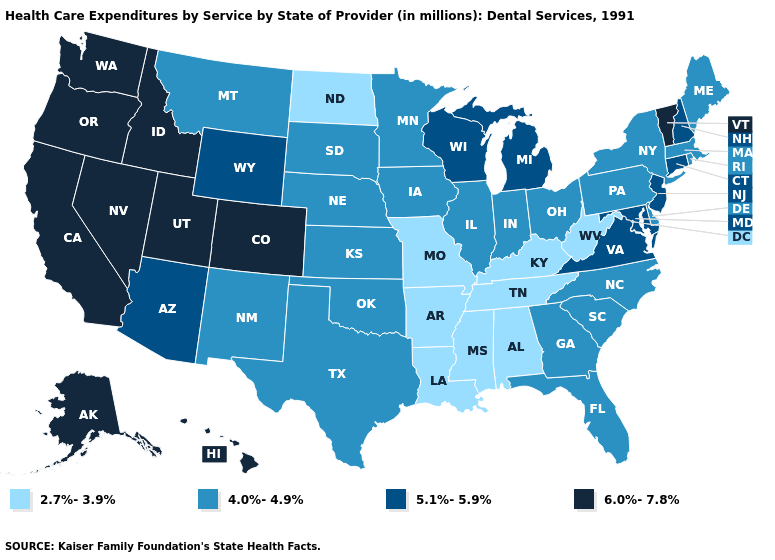Does Kansas have a higher value than Delaware?
Short answer required. No. Name the states that have a value in the range 5.1%-5.9%?
Be succinct. Arizona, Connecticut, Maryland, Michigan, New Hampshire, New Jersey, Virginia, Wisconsin, Wyoming. Does Montana have the same value as Wyoming?
Answer briefly. No. What is the lowest value in the MidWest?
Concise answer only. 2.7%-3.9%. What is the highest value in the Northeast ?
Answer briefly. 6.0%-7.8%. Among the states that border Maine , which have the highest value?
Quick response, please. New Hampshire. Which states have the highest value in the USA?
Keep it brief. Alaska, California, Colorado, Hawaii, Idaho, Nevada, Oregon, Utah, Vermont, Washington. Among the states that border North Carolina , which have the highest value?
Keep it brief. Virginia. What is the value of Florida?
Quick response, please. 4.0%-4.9%. Which states have the highest value in the USA?
Write a very short answer. Alaska, California, Colorado, Hawaii, Idaho, Nevada, Oregon, Utah, Vermont, Washington. Does Nevada have the highest value in the USA?
Answer briefly. Yes. What is the value of Oregon?
Give a very brief answer. 6.0%-7.8%. Which states hav the highest value in the South?
Write a very short answer. Maryland, Virginia. Does Nevada have the same value as Colorado?
Give a very brief answer. Yes. Does Arkansas have the lowest value in the USA?
Write a very short answer. Yes. 